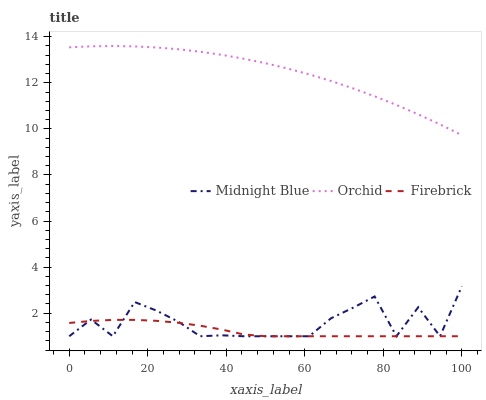Does Firebrick have the minimum area under the curve?
Answer yes or no. Yes. Does Orchid have the maximum area under the curve?
Answer yes or no. Yes. Does Midnight Blue have the minimum area under the curve?
Answer yes or no. No. Does Midnight Blue have the maximum area under the curve?
Answer yes or no. No. Is Orchid the smoothest?
Answer yes or no. Yes. Is Midnight Blue the roughest?
Answer yes or no. Yes. Is Midnight Blue the smoothest?
Answer yes or no. No. Is Orchid the roughest?
Answer yes or no. No. Does Firebrick have the lowest value?
Answer yes or no. Yes. Does Orchid have the lowest value?
Answer yes or no. No. Does Orchid have the highest value?
Answer yes or no. Yes. Does Midnight Blue have the highest value?
Answer yes or no. No. Is Midnight Blue less than Orchid?
Answer yes or no. Yes. Is Orchid greater than Firebrick?
Answer yes or no. Yes. Does Midnight Blue intersect Firebrick?
Answer yes or no. Yes. Is Midnight Blue less than Firebrick?
Answer yes or no. No. Is Midnight Blue greater than Firebrick?
Answer yes or no. No. Does Midnight Blue intersect Orchid?
Answer yes or no. No. 